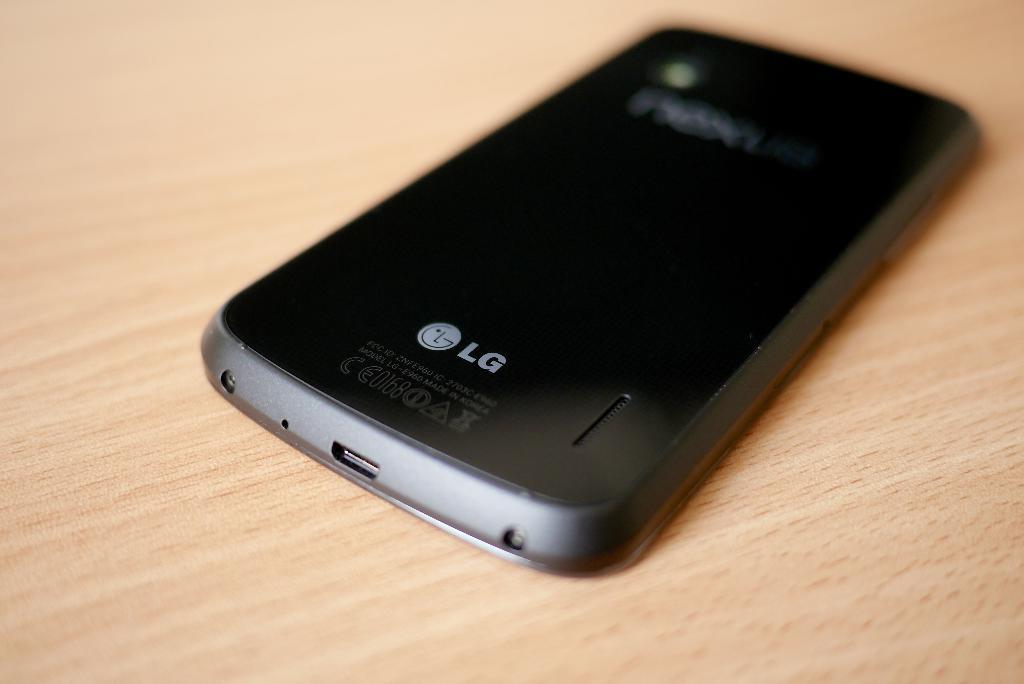In what country was this phone made in?
Ensure brevity in your answer.  Korea. What is the brand of the cell phone?
Ensure brevity in your answer.  Lg. 